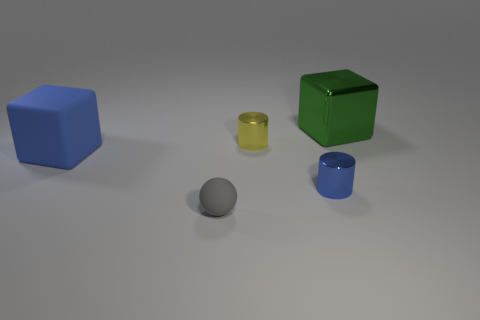What number of big cubes are to the left of the object that is in front of the small cylinder in front of the large blue cube? To the left of the small yellow cylinder, which is in front of the large blue cube, there is one large cube. This blue cube is situated on the far left of the arrangement. 